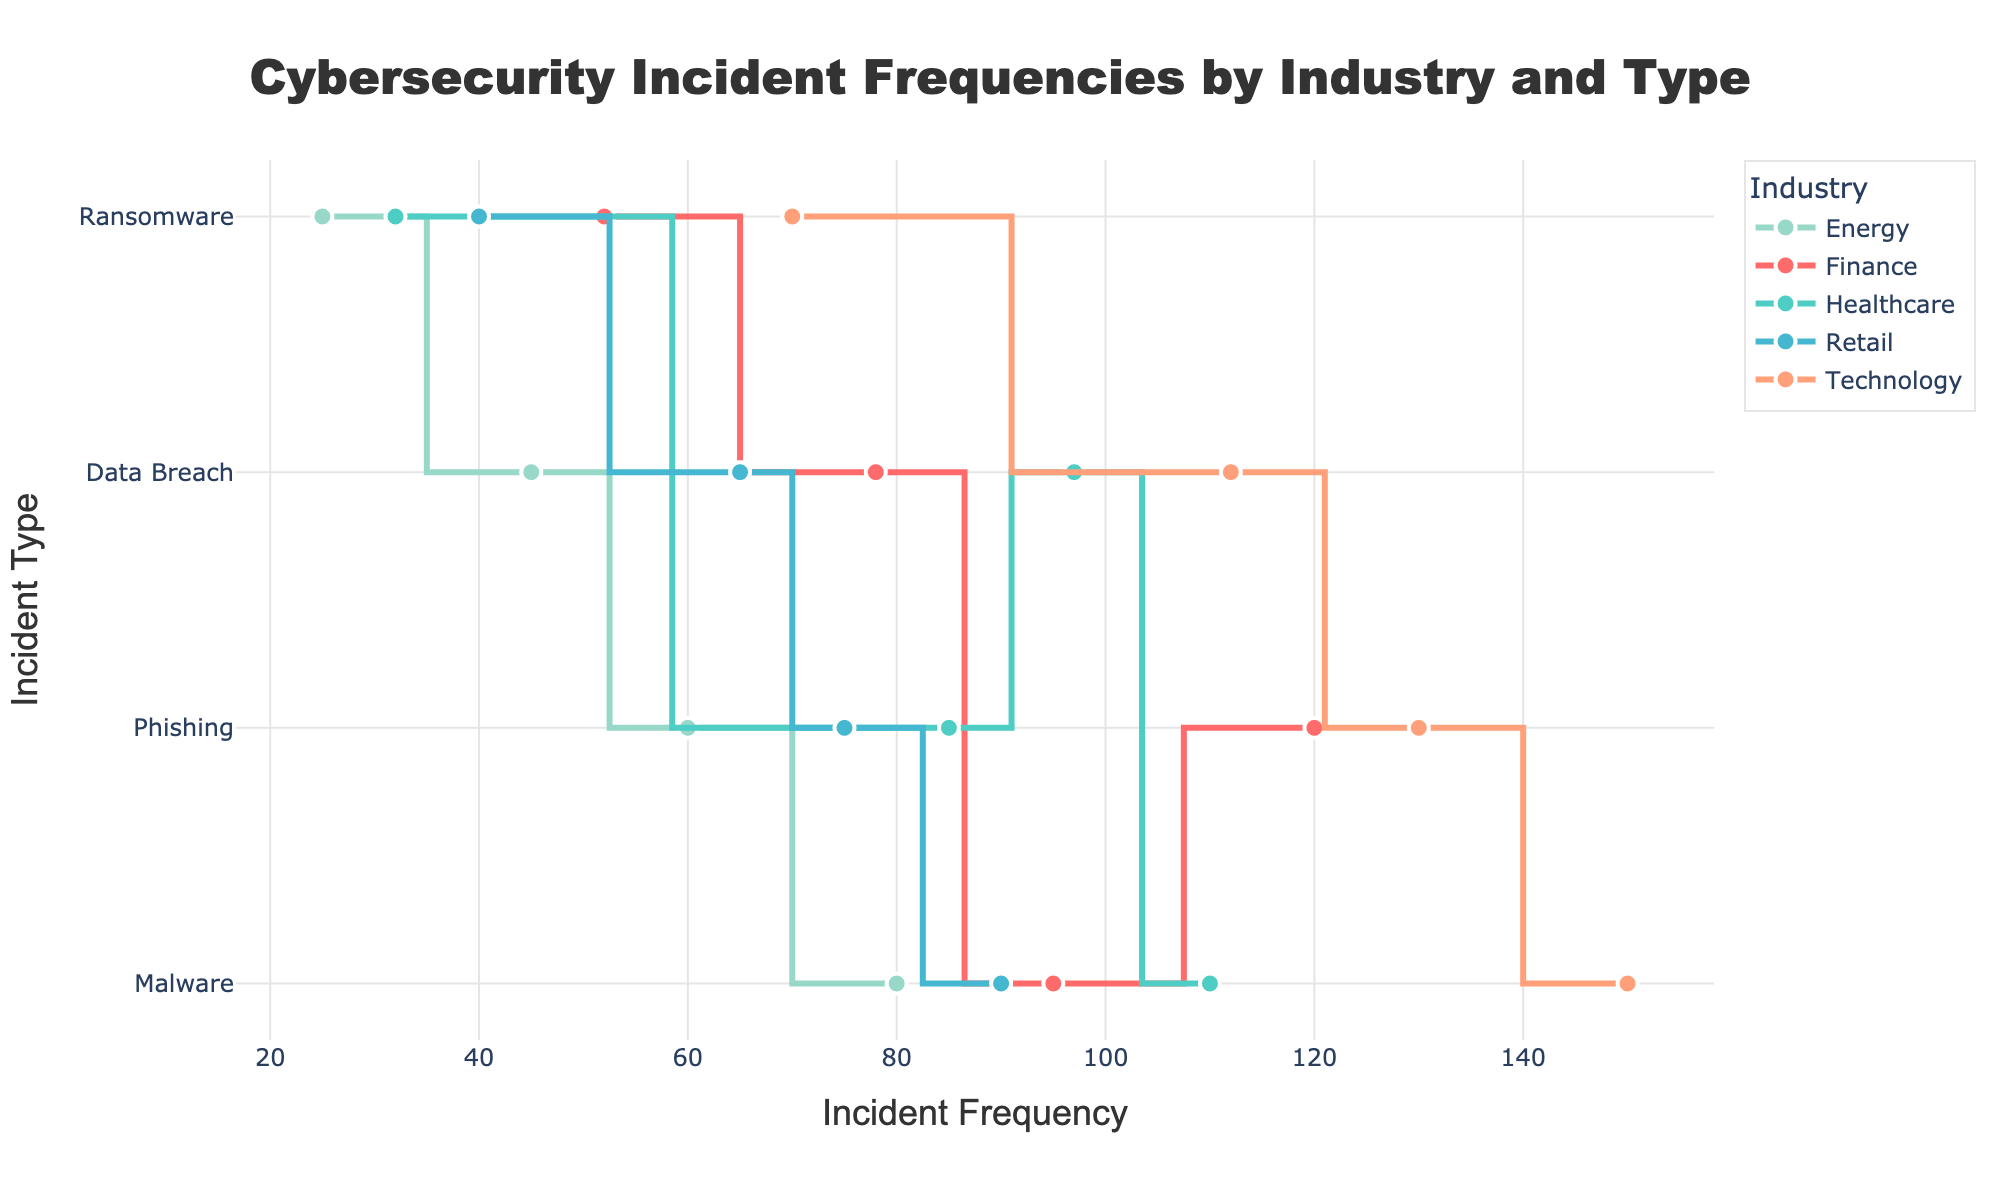What is the title of the figure? The title is usually displayed at the top of the figure. Here, it states "Cybersecurity Incident Frequencies by Industry and Type".
Answer: Cybersecurity Incident Frequencies by Industry and Type How many industries are represented in the figure? To find the number of industries, you look at the legend or count the unique colors representing different industries. In this figure, the industries are Finance, Healthcare, Retail, Technology, and Energy.
Answer: 5 Which cybersecurity incident type has the highest frequency in the Technology industry? Find the segment for Technology and then look for the highest frequency marker along the x-axis. The highest point is at 150 for Malware.
Answer: Malware Which industry has the least frequent ransomware incidents? Look at the ransomware markers across all industries and find the one with the smallest x-axis value. Here, the smallest frequency of 25 is in the Energy industry.
Answer: Energy What is the average impact score for data breaches across all industries? Locate the values for data breaches in each industry: Finance (8.5), Healthcare (9.0), Retail (8.0), Technology (9.0), and Energy (8.5). Sum them (8.5 + 9.0 + 8.0 + 9.0 + 8.5) to get 43 and divide by 5 data points.
Answer: 8.6 Which cybersecurity incident type shows the largest frequency difference between Finance and Retail industries? Compare the incident frequencies between Finance and Retail for Phishing, Malware, Ransomware, and Data Breach. Phishing has 120 (Finance) vs 75 (Retail) which is a difference of 45, the largest among all incident types.
Answer: Phishing What incident type has the highest impact score among all incidents for Healthcare? Review the impact scores for Healthcare: Phishing (8.0), Malware (6.5), Ransomware (8.5), and Data Breach (9.0). Data Breach has the highest impact score of 9.0.
Answer: Data Breach By how much does the incident frequency of phishing differ between Technology and Energy industries? Look for phishing incident frequencies for Technology and Energy: Technology (130) and Energy (60). Subtract to find the difference: 130 - 60.
Answer: 70 What type of cybersecurity incident has the second highest frequency in the Finance industry? For Finance, list frequencies: Phishing (120), Malware (95), Ransomware (52), Data Breach (78). The second highest frequency is 95 for Malware.
Answer: Malware 